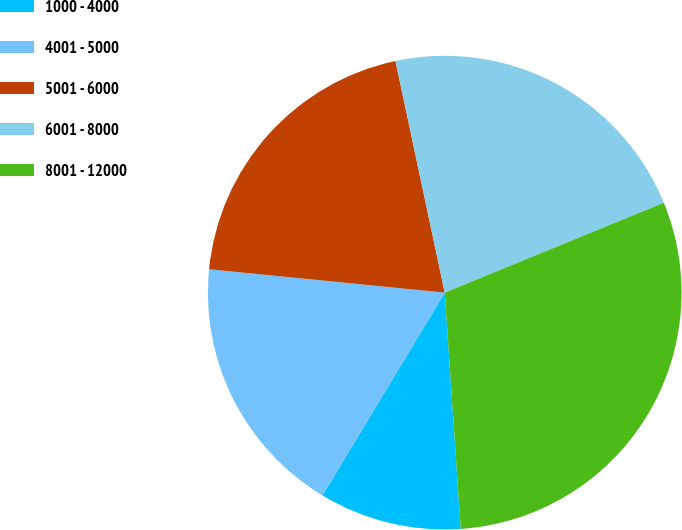Convert chart to OTSL. <chart><loc_0><loc_0><loc_500><loc_500><pie_chart><fcel>1000 - 4000<fcel>4001 - 5000<fcel>5001 - 6000<fcel>6001 - 8000<fcel>8001 - 12000<nl><fcel>9.71%<fcel>17.94%<fcel>20.09%<fcel>22.14%<fcel>30.12%<nl></chart> 